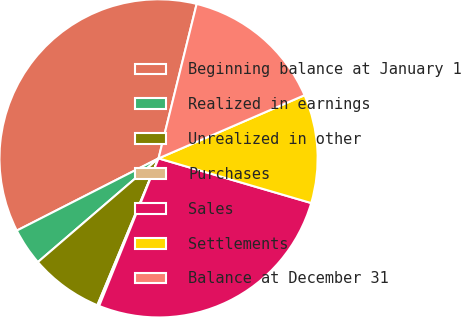Convert chart to OTSL. <chart><loc_0><loc_0><loc_500><loc_500><pie_chart><fcel>Beginning balance at January 1<fcel>Realized in earnings<fcel>Unrealized in other<fcel>Purchases<fcel>Sales<fcel>Settlements<fcel>Balance at December 31<nl><fcel>36.35%<fcel>3.8%<fcel>7.42%<fcel>0.19%<fcel>26.56%<fcel>11.03%<fcel>14.65%<nl></chart> 